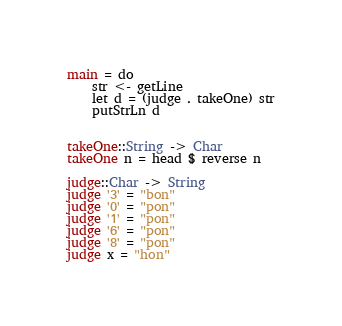<code> <loc_0><loc_0><loc_500><loc_500><_Haskell_>main = do
    str <- getLine
    let d = (judge . takeOne) str
    putStrLn d


takeOne::String -> Char
takeOne n = head $ reverse n 

judge::Char -> String
judge '3' = "bon"
judge '0' = "pon"
judge '1' = "pon"
judge '6' = "pon"
judge '8' = "pon"
judge x = "hon"</code> 